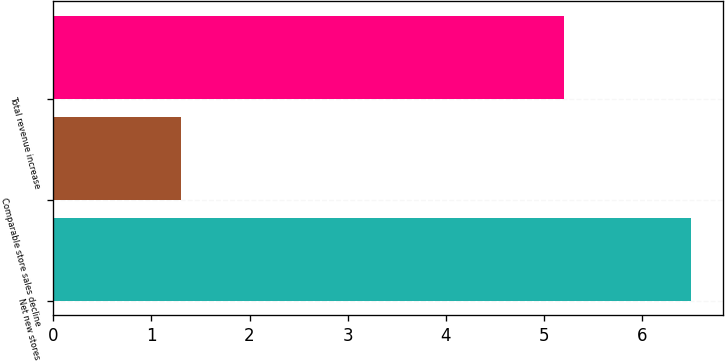Convert chart. <chart><loc_0><loc_0><loc_500><loc_500><bar_chart><fcel>Net new stores<fcel>Comparable store sales decline<fcel>Total revenue increase<nl><fcel>6.5<fcel>1.3<fcel>5.2<nl></chart> 